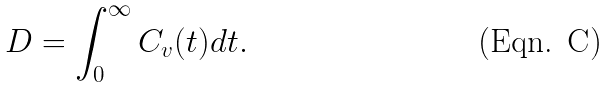<formula> <loc_0><loc_0><loc_500><loc_500>D = \int _ { 0 } ^ { \infty } C _ { v } ( t ) d t .</formula> 